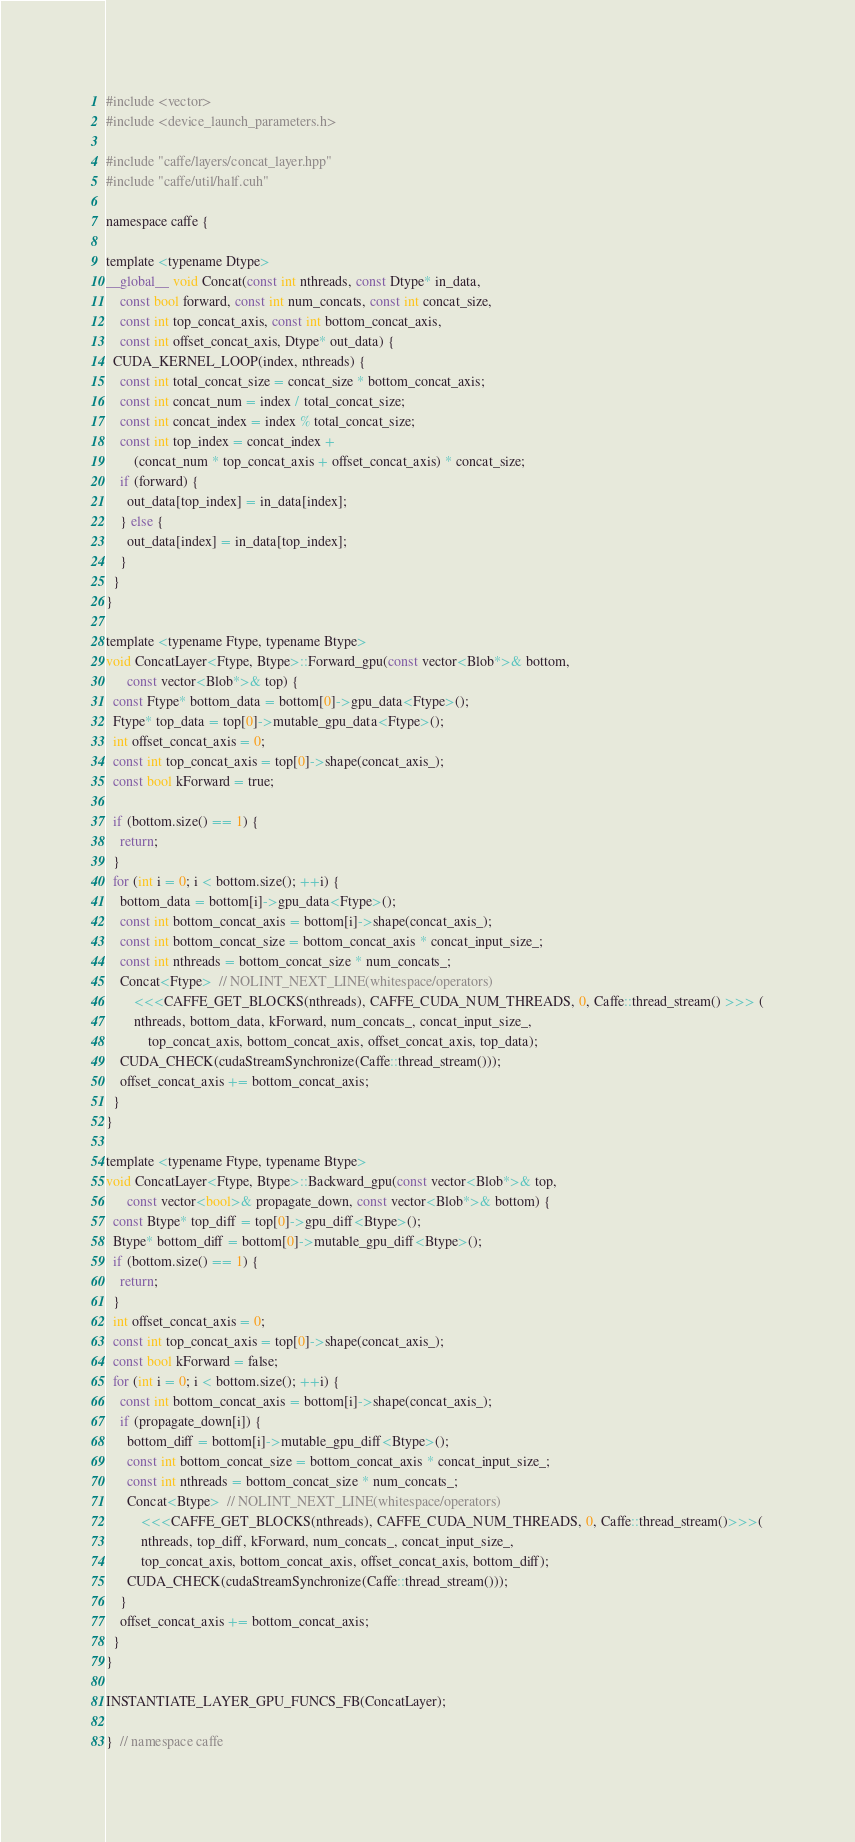Convert code to text. <code><loc_0><loc_0><loc_500><loc_500><_Cuda_>#include <vector>
#include <device_launch_parameters.h>

#include "caffe/layers/concat_layer.hpp"
#include "caffe/util/half.cuh"

namespace caffe {

template <typename Dtype>
__global__ void Concat(const int nthreads, const Dtype* in_data,
    const bool forward, const int num_concats, const int concat_size,
    const int top_concat_axis, const int bottom_concat_axis,
    const int offset_concat_axis, Dtype* out_data) {
  CUDA_KERNEL_LOOP(index, nthreads) {
    const int total_concat_size = concat_size * bottom_concat_axis;
    const int concat_num = index / total_concat_size;
    const int concat_index = index % total_concat_size;
    const int top_index = concat_index +
        (concat_num * top_concat_axis + offset_concat_axis) * concat_size;
    if (forward) {
      out_data[top_index] = in_data[index];
    } else {
      out_data[index] = in_data[top_index];
    }
  }
}

template <typename Ftype, typename Btype>
void ConcatLayer<Ftype, Btype>::Forward_gpu(const vector<Blob*>& bottom,
      const vector<Blob*>& top) {
  const Ftype* bottom_data = bottom[0]->gpu_data<Ftype>();
  Ftype* top_data = top[0]->mutable_gpu_data<Ftype>();
  int offset_concat_axis = 0;
  const int top_concat_axis = top[0]->shape(concat_axis_);
  const bool kForward = true;

  if (bottom.size() == 1) {
    return;
  }
  for (int i = 0; i < bottom.size(); ++i) {
    bottom_data = bottom[i]->gpu_data<Ftype>();
    const int bottom_concat_axis = bottom[i]->shape(concat_axis_);
    const int bottom_concat_size = bottom_concat_axis * concat_input_size_;
    const int nthreads = bottom_concat_size * num_concats_;
    Concat<Ftype>  // NOLINT_NEXT_LINE(whitespace/operators)
        <<<CAFFE_GET_BLOCKS(nthreads), CAFFE_CUDA_NUM_THREADS, 0, Caffe::thread_stream() >>> (
        nthreads, bottom_data, kForward, num_concats_, concat_input_size_,
            top_concat_axis, bottom_concat_axis, offset_concat_axis, top_data);
    CUDA_CHECK(cudaStreamSynchronize(Caffe::thread_stream()));
    offset_concat_axis += bottom_concat_axis;
  }
}

template <typename Ftype, typename Btype>
void ConcatLayer<Ftype, Btype>::Backward_gpu(const vector<Blob*>& top,
      const vector<bool>& propagate_down, const vector<Blob*>& bottom) {
  const Btype* top_diff = top[0]->gpu_diff<Btype>();
  Btype* bottom_diff = bottom[0]->mutable_gpu_diff<Btype>();
  if (bottom.size() == 1) {
    return;
  }
  int offset_concat_axis = 0;
  const int top_concat_axis = top[0]->shape(concat_axis_);
  const bool kForward = false;
  for (int i = 0; i < bottom.size(); ++i) {
    const int bottom_concat_axis = bottom[i]->shape(concat_axis_);
    if (propagate_down[i]) {
      bottom_diff = bottom[i]->mutable_gpu_diff<Btype>();
      const int bottom_concat_size = bottom_concat_axis * concat_input_size_;
      const int nthreads = bottom_concat_size * num_concats_;
      Concat<Btype>  // NOLINT_NEXT_LINE(whitespace/operators)
          <<<CAFFE_GET_BLOCKS(nthreads), CAFFE_CUDA_NUM_THREADS, 0, Caffe::thread_stream()>>>(
          nthreads, top_diff, kForward, num_concats_, concat_input_size_,
          top_concat_axis, bottom_concat_axis, offset_concat_axis, bottom_diff);
      CUDA_CHECK(cudaStreamSynchronize(Caffe::thread_stream()));
    }
    offset_concat_axis += bottom_concat_axis;
  }
}

INSTANTIATE_LAYER_GPU_FUNCS_FB(ConcatLayer);

}  // namespace caffe
</code> 